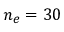<formula> <loc_0><loc_0><loc_500><loc_500>n _ { e } = 3 0 \</formula> 